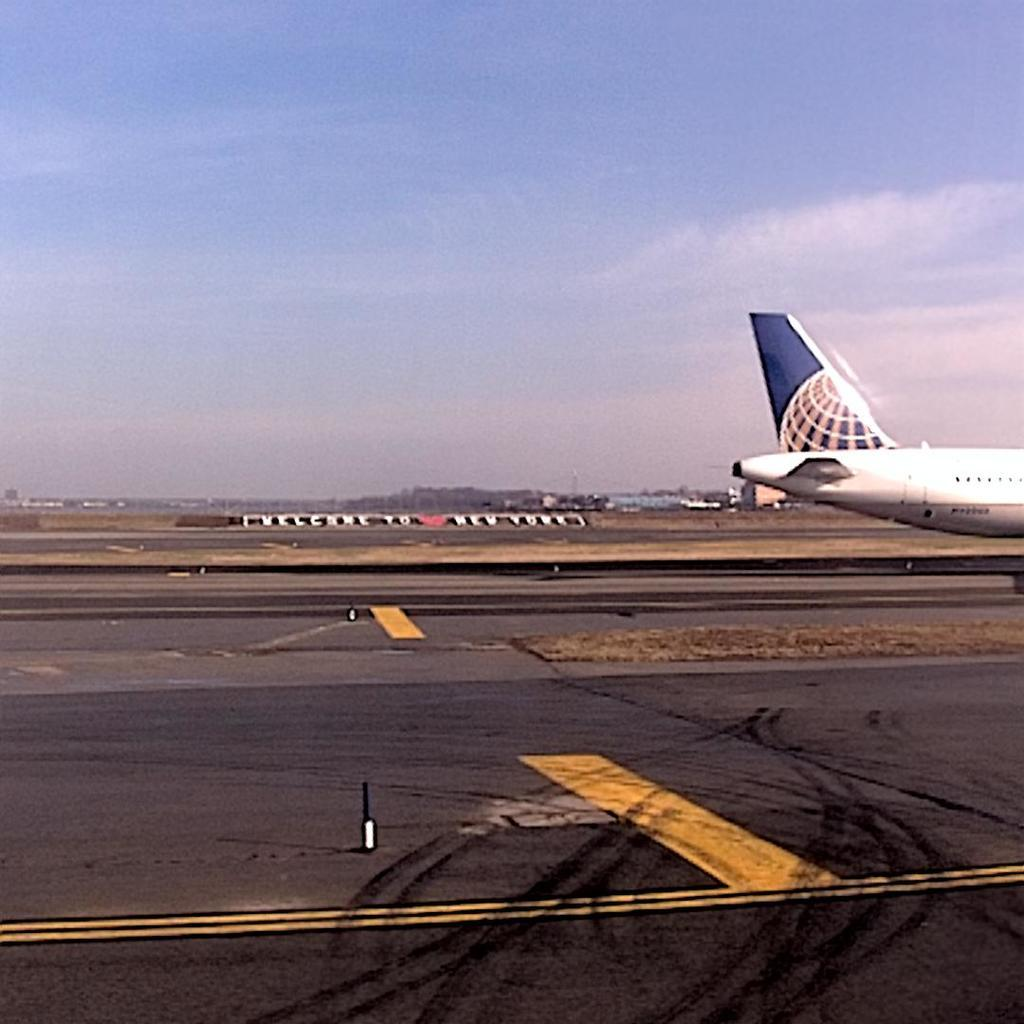What is the unusual object on the road in the image? There is an aircraft on the road in the image. What can be seen in the distance behind the aircraft? There are trees visible in the background. What is visible in the sky in the image? Clouds are present in the sky, and the sky is visible in the background. What type of vessel is floating in the water near the aircraft? There is no water or vessel present in the image; it features an aircraft on the road with trees and clouds in the background. 